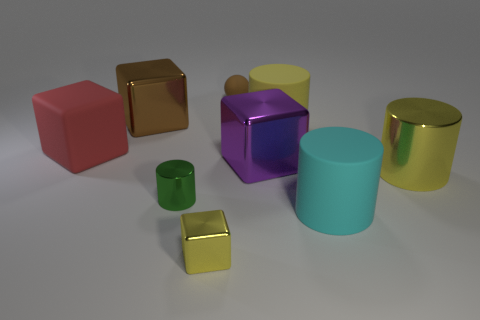Subtract all purple cylinders. Subtract all brown spheres. How many cylinders are left? 4 Subtract all spheres. How many objects are left? 8 Add 3 small cylinders. How many small cylinders exist? 4 Subtract 0 green balls. How many objects are left? 9 Subtract all yellow rubber cylinders. Subtract all tiny yellow shiny things. How many objects are left? 7 Add 3 brown cubes. How many brown cubes are left? 4 